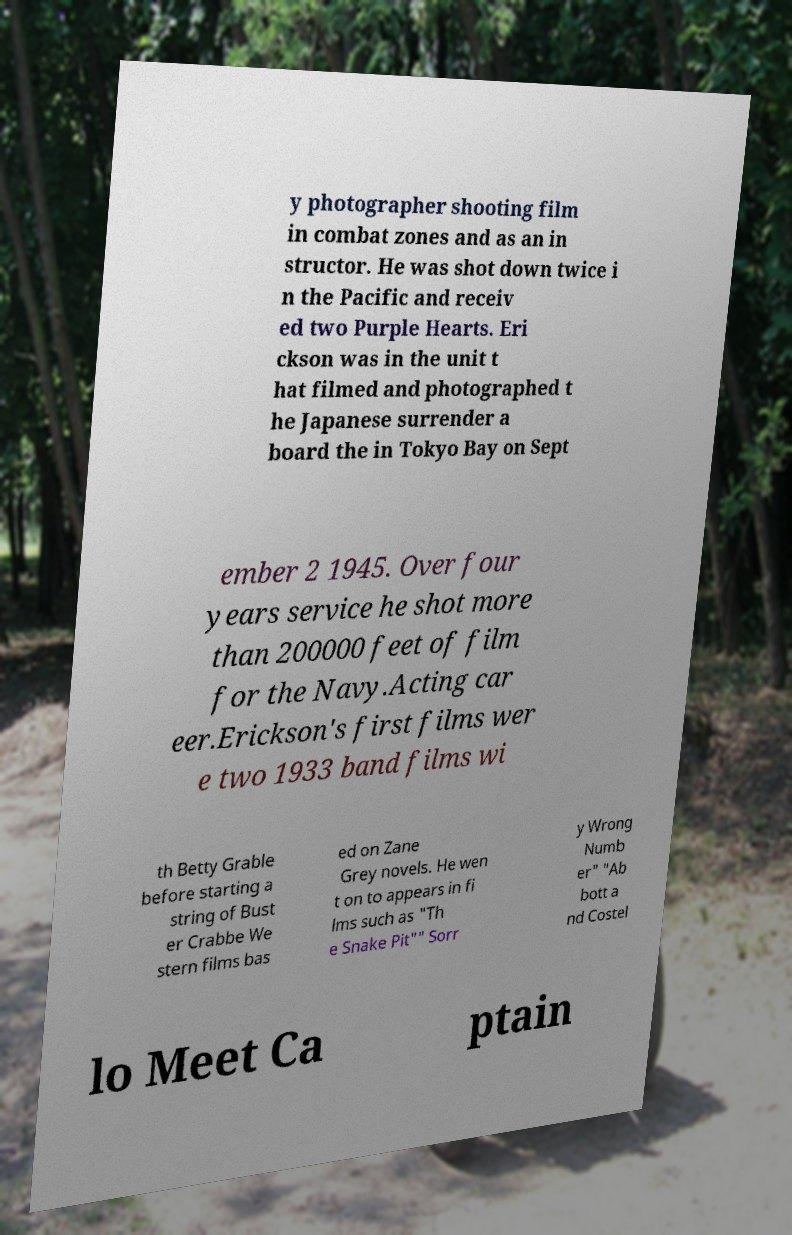I need the written content from this picture converted into text. Can you do that? y photographer shooting film in combat zones and as an in structor. He was shot down twice i n the Pacific and receiv ed two Purple Hearts. Eri ckson was in the unit t hat filmed and photographed t he Japanese surrender a board the in Tokyo Bay on Sept ember 2 1945. Over four years service he shot more than 200000 feet of film for the Navy.Acting car eer.Erickson's first films wer e two 1933 band films wi th Betty Grable before starting a string of Bust er Crabbe We stern films bas ed on Zane Grey novels. He wen t on to appears in fi lms such as "Th e Snake Pit"" Sorr y Wrong Numb er" "Ab bott a nd Costel lo Meet Ca ptain 